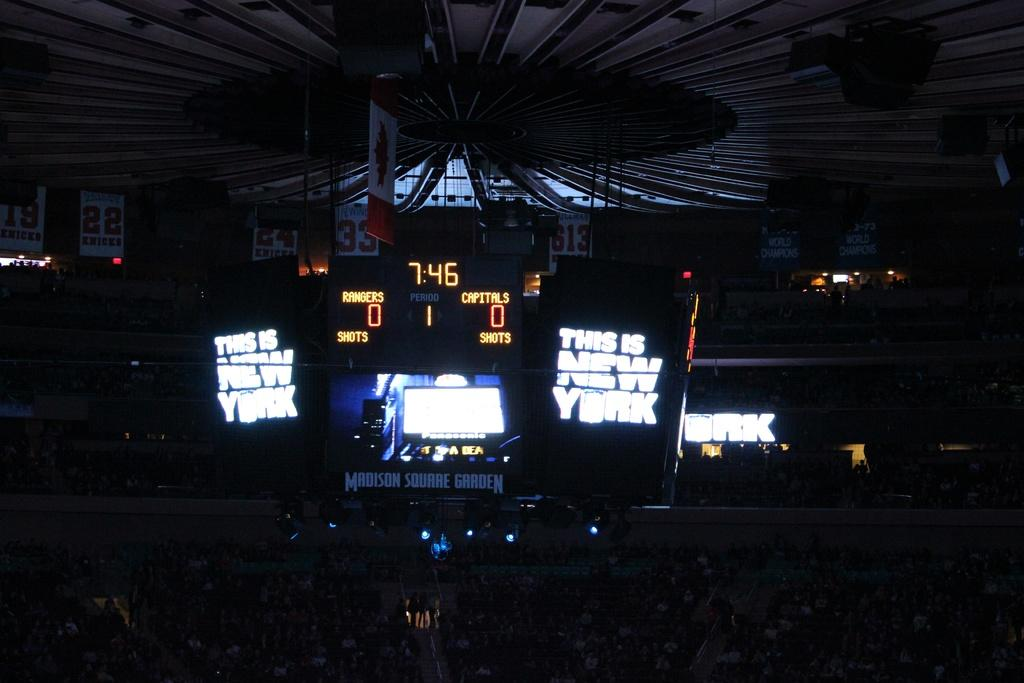<image>
Give a short and clear explanation of the subsequent image. The score of the game is 0:0 at 7:46. 